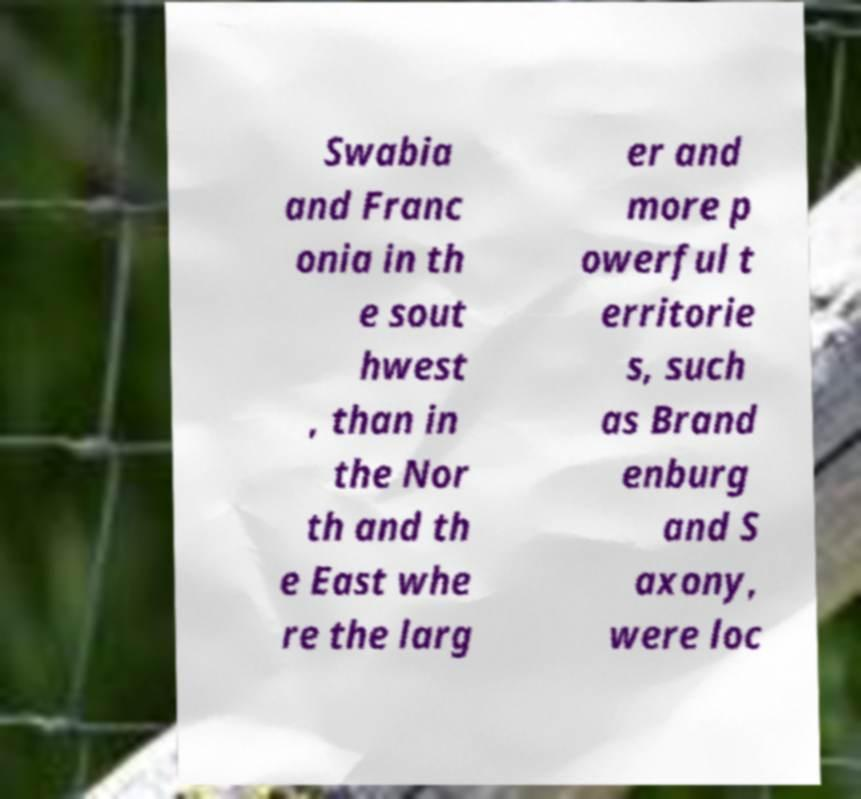Can you read and provide the text displayed in the image?This photo seems to have some interesting text. Can you extract and type it out for me? Swabia and Franc onia in th e sout hwest , than in the Nor th and th e East whe re the larg er and more p owerful t erritorie s, such as Brand enburg and S axony, were loc 